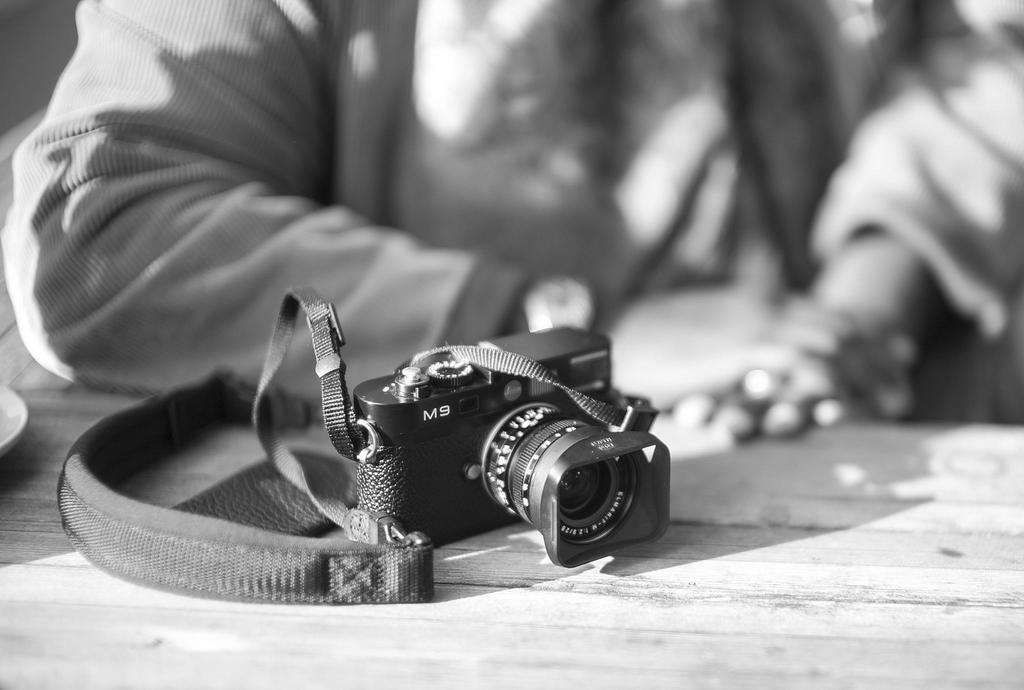Provide a one-sentence caption for the provided image. A black and white photo of a camera labeled M9 in front of a person. 